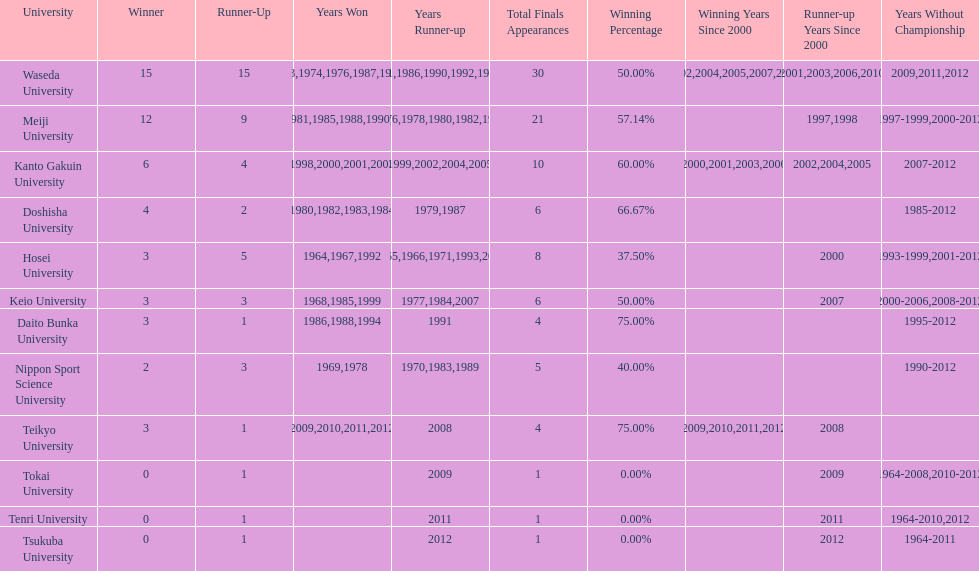Which university had the most years won? Waseda University. 